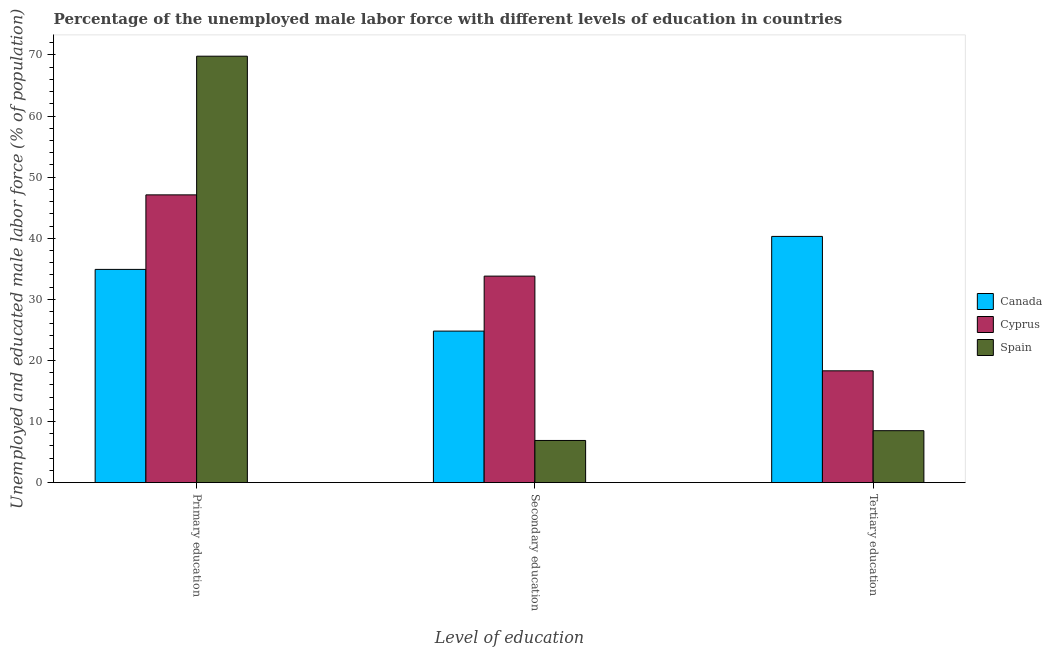Are the number of bars per tick equal to the number of legend labels?
Ensure brevity in your answer.  Yes. Are the number of bars on each tick of the X-axis equal?
Your answer should be compact. Yes. How many bars are there on the 2nd tick from the left?
Ensure brevity in your answer.  3. How many bars are there on the 3rd tick from the right?
Give a very brief answer. 3. What is the label of the 2nd group of bars from the left?
Your answer should be very brief. Secondary education. What is the percentage of male labor force who received tertiary education in Cyprus?
Provide a succinct answer. 18.3. Across all countries, what is the maximum percentage of male labor force who received tertiary education?
Your answer should be very brief. 40.3. Across all countries, what is the minimum percentage of male labor force who received secondary education?
Give a very brief answer. 6.9. In which country was the percentage of male labor force who received primary education maximum?
Keep it short and to the point. Spain. In which country was the percentage of male labor force who received primary education minimum?
Provide a short and direct response. Canada. What is the total percentage of male labor force who received tertiary education in the graph?
Your answer should be compact. 67.1. What is the difference between the percentage of male labor force who received primary education in Cyprus and that in Spain?
Offer a terse response. -22.7. What is the difference between the percentage of male labor force who received primary education in Cyprus and the percentage of male labor force who received tertiary education in Spain?
Your response must be concise. 38.6. What is the average percentage of male labor force who received secondary education per country?
Give a very brief answer. 21.83. What is the difference between the percentage of male labor force who received primary education and percentage of male labor force who received tertiary education in Canada?
Provide a succinct answer. -5.4. In how many countries, is the percentage of male labor force who received tertiary education greater than 26 %?
Offer a very short reply. 1. What is the ratio of the percentage of male labor force who received tertiary education in Canada to that in Spain?
Your answer should be very brief. 4.74. What is the difference between the highest and the second highest percentage of male labor force who received primary education?
Make the answer very short. 22.7. What is the difference between the highest and the lowest percentage of male labor force who received secondary education?
Your response must be concise. 26.9. In how many countries, is the percentage of male labor force who received secondary education greater than the average percentage of male labor force who received secondary education taken over all countries?
Provide a short and direct response. 2. Is the sum of the percentage of male labor force who received secondary education in Canada and Cyprus greater than the maximum percentage of male labor force who received tertiary education across all countries?
Provide a short and direct response. Yes. What does the 1st bar from the left in Secondary education represents?
Provide a succinct answer. Canada. What does the 1st bar from the right in Primary education represents?
Offer a very short reply. Spain. Is it the case that in every country, the sum of the percentage of male labor force who received primary education and percentage of male labor force who received secondary education is greater than the percentage of male labor force who received tertiary education?
Offer a terse response. Yes. Does the graph contain grids?
Ensure brevity in your answer.  No. How many legend labels are there?
Offer a terse response. 3. How are the legend labels stacked?
Give a very brief answer. Vertical. What is the title of the graph?
Keep it short and to the point. Percentage of the unemployed male labor force with different levels of education in countries. Does "Lao PDR" appear as one of the legend labels in the graph?
Offer a terse response. No. What is the label or title of the X-axis?
Your response must be concise. Level of education. What is the label or title of the Y-axis?
Your answer should be very brief. Unemployed and educated male labor force (% of population). What is the Unemployed and educated male labor force (% of population) of Canada in Primary education?
Your answer should be compact. 34.9. What is the Unemployed and educated male labor force (% of population) of Cyprus in Primary education?
Make the answer very short. 47.1. What is the Unemployed and educated male labor force (% of population) in Spain in Primary education?
Give a very brief answer. 69.8. What is the Unemployed and educated male labor force (% of population) of Canada in Secondary education?
Provide a succinct answer. 24.8. What is the Unemployed and educated male labor force (% of population) in Cyprus in Secondary education?
Offer a very short reply. 33.8. What is the Unemployed and educated male labor force (% of population) in Spain in Secondary education?
Your answer should be compact. 6.9. What is the Unemployed and educated male labor force (% of population) of Canada in Tertiary education?
Offer a very short reply. 40.3. What is the Unemployed and educated male labor force (% of population) of Cyprus in Tertiary education?
Your response must be concise. 18.3. Across all Level of education, what is the maximum Unemployed and educated male labor force (% of population) in Canada?
Offer a very short reply. 40.3. Across all Level of education, what is the maximum Unemployed and educated male labor force (% of population) of Cyprus?
Provide a short and direct response. 47.1. Across all Level of education, what is the maximum Unemployed and educated male labor force (% of population) in Spain?
Offer a very short reply. 69.8. Across all Level of education, what is the minimum Unemployed and educated male labor force (% of population) of Canada?
Give a very brief answer. 24.8. Across all Level of education, what is the minimum Unemployed and educated male labor force (% of population) in Cyprus?
Ensure brevity in your answer.  18.3. Across all Level of education, what is the minimum Unemployed and educated male labor force (% of population) of Spain?
Your answer should be compact. 6.9. What is the total Unemployed and educated male labor force (% of population) in Canada in the graph?
Make the answer very short. 100. What is the total Unemployed and educated male labor force (% of population) in Cyprus in the graph?
Provide a short and direct response. 99.2. What is the total Unemployed and educated male labor force (% of population) in Spain in the graph?
Your answer should be compact. 85.2. What is the difference between the Unemployed and educated male labor force (% of population) of Canada in Primary education and that in Secondary education?
Your answer should be very brief. 10.1. What is the difference between the Unemployed and educated male labor force (% of population) in Cyprus in Primary education and that in Secondary education?
Ensure brevity in your answer.  13.3. What is the difference between the Unemployed and educated male labor force (% of population) of Spain in Primary education and that in Secondary education?
Your answer should be compact. 62.9. What is the difference between the Unemployed and educated male labor force (% of population) of Cyprus in Primary education and that in Tertiary education?
Make the answer very short. 28.8. What is the difference between the Unemployed and educated male labor force (% of population) of Spain in Primary education and that in Tertiary education?
Your answer should be very brief. 61.3. What is the difference between the Unemployed and educated male labor force (% of population) in Canada in Secondary education and that in Tertiary education?
Provide a short and direct response. -15.5. What is the difference between the Unemployed and educated male labor force (% of population) in Spain in Secondary education and that in Tertiary education?
Your answer should be very brief. -1.6. What is the difference between the Unemployed and educated male labor force (% of population) of Canada in Primary education and the Unemployed and educated male labor force (% of population) of Cyprus in Secondary education?
Your answer should be compact. 1.1. What is the difference between the Unemployed and educated male labor force (% of population) in Canada in Primary education and the Unemployed and educated male labor force (% of population) in Spain in Secondary education?
Offer a terse response. 28. What is the difference between the Unemployed and educated male labor force (% of population) in Cyprus in Primary education and the Unemployed and educated male labor force (% of population) in Spain in Secondary education?
Keep it short and to the point. 40.2. What is the difference between the Unemployed and educated male labor force (% of population) in Canada in Primary education and the Unemployed and educated male labor force (% of population) in Cyprus in Tertiary education?
Your answer should be compact. 16.6. What is the difference between the Unemployed and educated male labor force (% of population) of Canada in Primary education and the Unemployed and educated male labor force (% of population) of Spain in Tertiary education?
Ensure brevity in your answer.  26.4. What is the difference between the Unemployed and educated male labor force (% of population) of Cyprus in Primary education and the Unemployed and educated male labor force (% of population) of Spain in Tertiary education?
Offer a very short reply. 38.6. What is the difference between the Unemployed and educated male labor force (% of population) in Cyprus in Secondary education and the Unemployed and educated male labor force (% of population) in Spain in Tertiary education?
Give a very brief answer. 25.3. What is the average Unemployed and educated male labor force (% of population) in Canada per Level of education?
Offer a very short reply. 33.33. What is the average Unemployed and educated male labor force (% of population) of Cyprus per Level of education?
Your answer should be compact. 33.07. What is the average Unemployed and educated male labor force (% of population) in Spain per Level of education?
Ensure brevity in your answer.  28.4. What is the difference between the Unemployed and educated male labor force (% of population) of Canada and Unemployed and educated male labor force (% of population) of Cyprus in Primary education?
Your answer should be very brief. -12.2. What is the difference between the Unemployed and educated male labor force (% of population) of Canada and Unemployed and educated male labor force (% of population) of Spain in Primary education?
Provide a succinct answer. -34.9. What is the difference between the Unemployed and educated male labor force (% of population) of Cyprus and Unemployed and educated male labor force (% of population) of Spain in Primary education?
Offer a terse response. -22.7. What is the difference between the Unemployed and educated male labor force (% of population) of Cyprus and Unemployed and educated male labor force (% of population) of Spain in Secondary education?
Offer a terse response. 26.9. What is the difference between the Unemployed and educated male labor force (% of population) in Canada and Unemployed and educated male labor force (% of population) in Spain in Tertiary education?
Provide a succinct answer. 31.8. What is the difference between the Unemployed and educated male labor force (% of population) of Cyprus and Unemployed and educated male labor force (% of population) of Spain in Tertiary education?
Ensure brevity in your answer.  9.8. What is the ratio of the Unemployed and educated male labor force (% of population) of Canada in Primary education to that in Secondary education?
Provide a succinct answer. 1.41. What is the ratio of the Unemployed and educated male labor force (% of population) of Cyprus in Primary education to that in Secondary education?
Ensure brevity in your answer.  1.39. What is the ratio of the Unemployed and educated male labor force (% of population) in Spain in Primary education to that in Secondary education?
Your answer should be compact. 10.12. What is the ratio of the Unemployed and educated male labor force (% of population) in Canada in Primary education to that in Tertiary education?
Your answer should be very brief. 0.87. What is the ratio of the Unemployed and educated male labor force (% of population) in Cyprus in Primary education to that in Tertiary education?
Keep it short and to the point. 2.57. What is the ratio of the Unemployed and educated male labor force (% of population) of Spain in Primary education to that in Tertiary education?
Keep it short and to the point. 8.21. What is the ratio of the Unemployed and educated male labor force (% of population) in Canada in Secondary education to that in Tertiary education?
Provide a short and direct response. 0.62. What is the ratio of the Unemployed and educated male labor force (% of population) of Cyprus in Secondary education to that in Tertiary education?
Your answer should be very brief. 1.85. What is the ratio of the Unemployed and educated male labor force (% of population) of Spain in Secondary education to that in Tertiary education?
Ensure brevity in your answer.  0.81. What is the difference between the highest and the second highest Unemployed and educated male labor force (% of population) in Canada?
Your answer should be compact. 5.4. What is the difference between the highest and the second highest Unemployed and educated male labor force (% of population) in Cyprus?
Provide a short and direct response. 13.3. What is the difference between the highest and the second highest Unemployed and educated male labor force (% of population) of Spain?
Offer a very short reply. 61.3. What is the difference between the highest and the lowest Unemployed and educated male labor force (% of population) of Cyprus?
Provide a succinct answer. 28.8. What is the difference between the highest and the lowest Unemployed and educated male labor force (% of population) in Spain?
Keep it short and to the point. 62.9. 